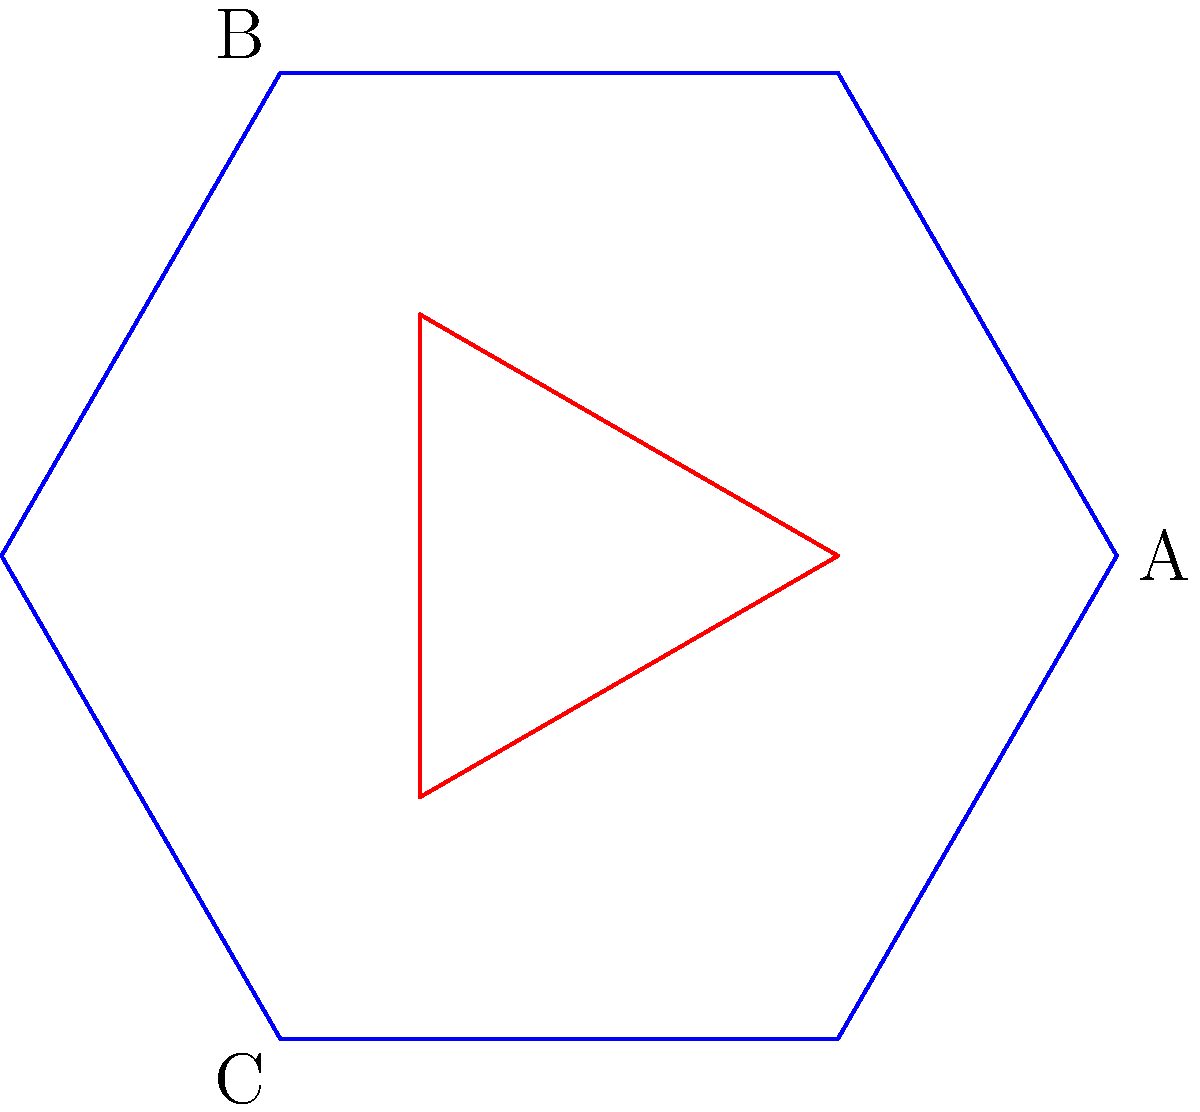In a hypothetical multiverse where alien crystal structures exhibit unique symmetries, consider the diagram above representing a cross-section of a fictional alien crystal. If this structure were to undergo a quantum fluctuation that rotates it by 120° clockwise, which point would align with the current position of point A? To solve this problem, we need to analyze the symmetry of the alien crystal structure and understand the effects of a 120° clockwise rotation. Let's break it down step-by-step:

1. Observe the crystal structure:
   - The outer shape is a regular hexagon (blue) with 6-fold rotational symmetry.
   - The inner shape is an equilateral triangle (red) with 3-fold rotational symmetry.

2. Understand the rotation:
   - A 120° clockwise rotation is equivalent to a one-third turn of the entire structure.
   - This rotation aligns with the 3-fold symmetry of the inner triangle.

3. Analyze the points:
   - Point A is on the outer hexagon, at one of its vertices.
   - Points B and C are on the inner triangle, at two of its vertices.

4. Apply the rotation:
   - A 120° clockwise rotation will move each point to the position of the next point in a clockwise direction.
   - The outer hexagon has six vertices, but we're only concerned with the three that align with the inner triangle.

5. Trace the movement:
   - Point A will move to the position currently occupied by point C.
   - Point C will move to the position currently occupied by point B.
   - Point B will move to the position currently occupied by point A.

6. Conclude:
   - After the 120° clockwise rotation, point B will align with the current position of point A.

This analysis demonstrates how understanding symmetry and rotational transformations in crystal structures can be applied to predict structural changes in hypothetical quantum scenarios, bridging the gap between crystallography and multiverse theory.
Answer: B 